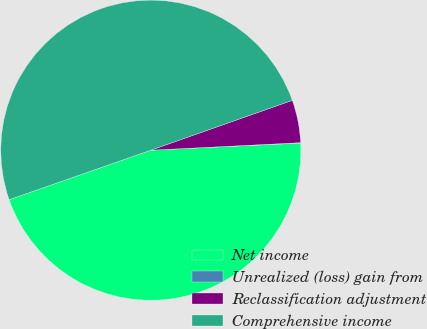Convert chart to OTSL. <chart><loc_0><loc_0><loc_500><loc_500><pie_chart><fcel>Net income<fcel>Unrealized (loss) gain from<fcel>Reclassification adjustment<fcel>Comprehensive income<nl><fcel>45.41%<fcel>0.04%<fcel>4.59%<fcel>49.96%<nl></chart> 